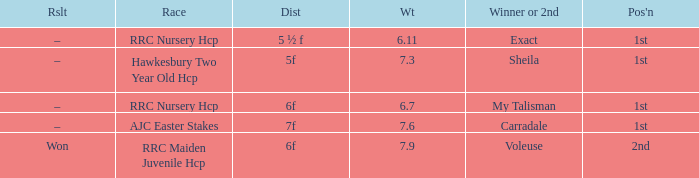What is the weight number when the distance was 5 ½ f? 1.0. 